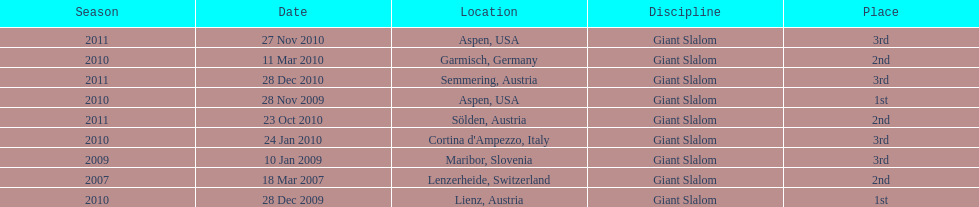What is the total number of her 2nd place finishes on the list? 3. 